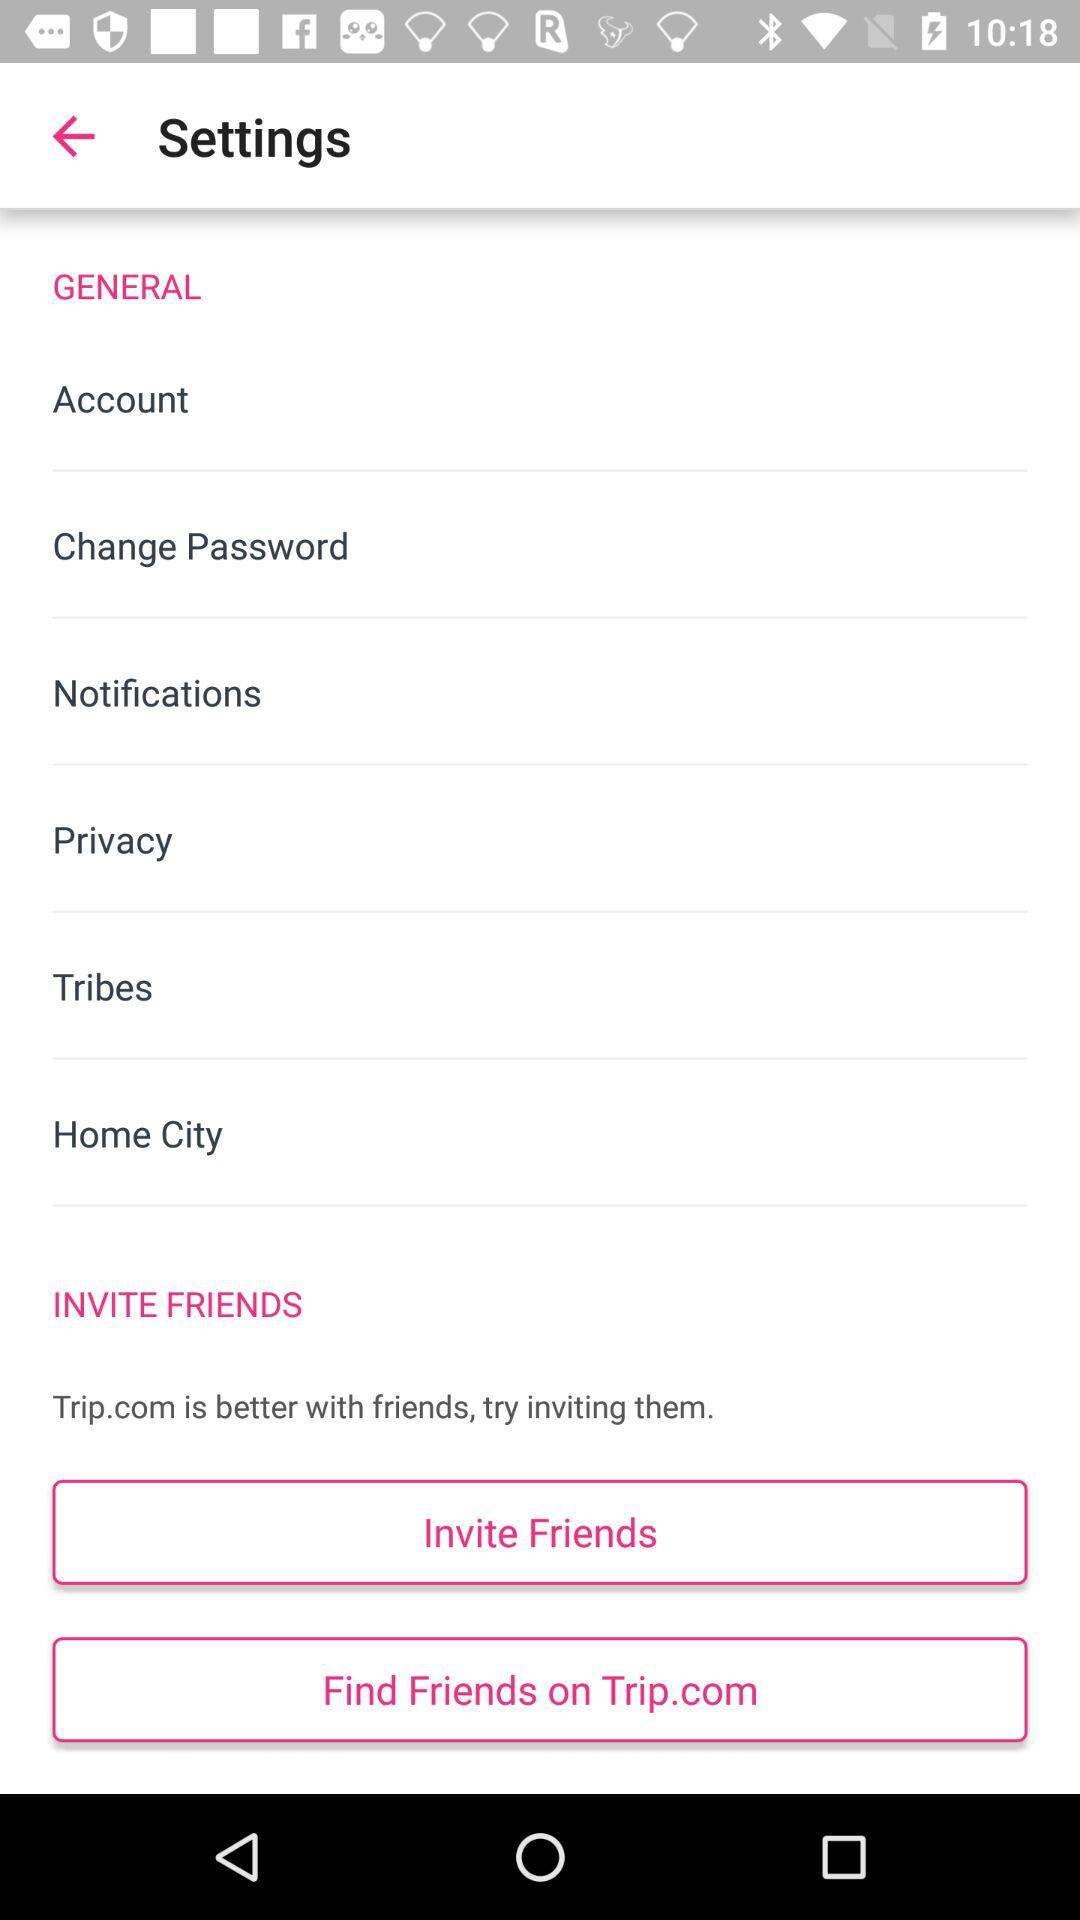What is the name of the application? The name of the application is "Trip.com". 